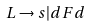Convert formula to latex. <formula><loc_0><loc_0><loc_500><loc_500>L \rightarrow s | d F d</formula> 